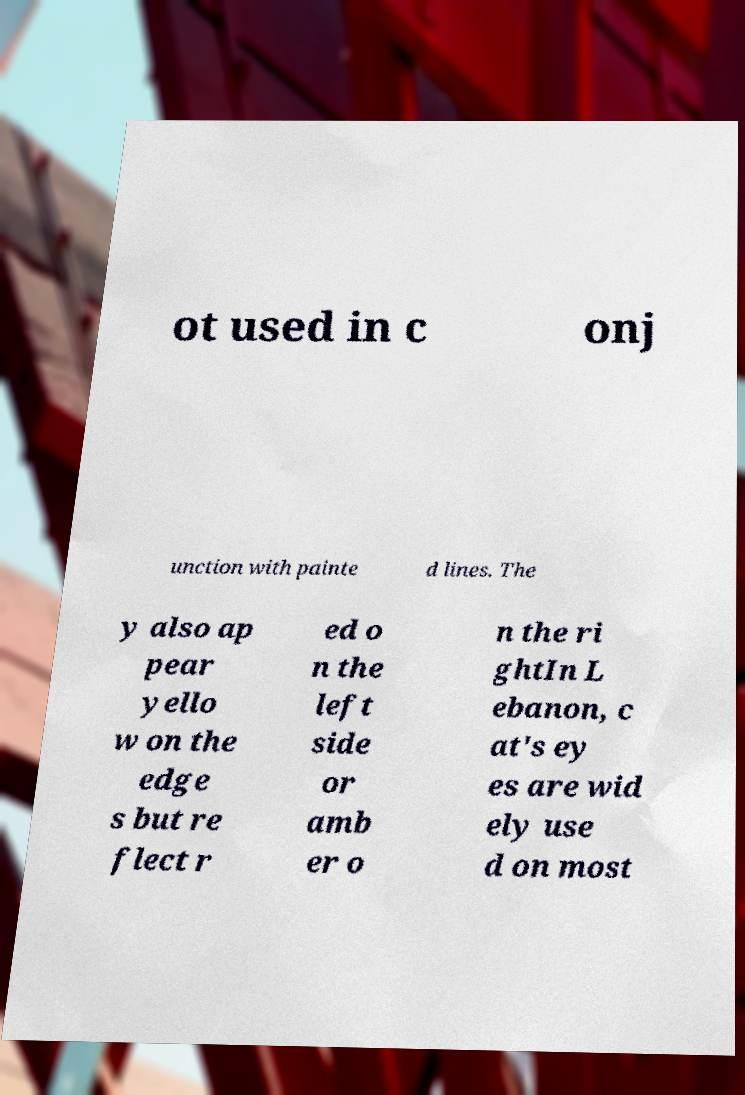What messages or text are displayed in this image? I need them in a readable, typed format. ot used in c onj unction with painte d lines. The y also ap pear yello w on the edge s but re flect r ed o n the left side or amb er o n the ri ghtIn L ebanon, c at's ey es are wid ely use d on most 